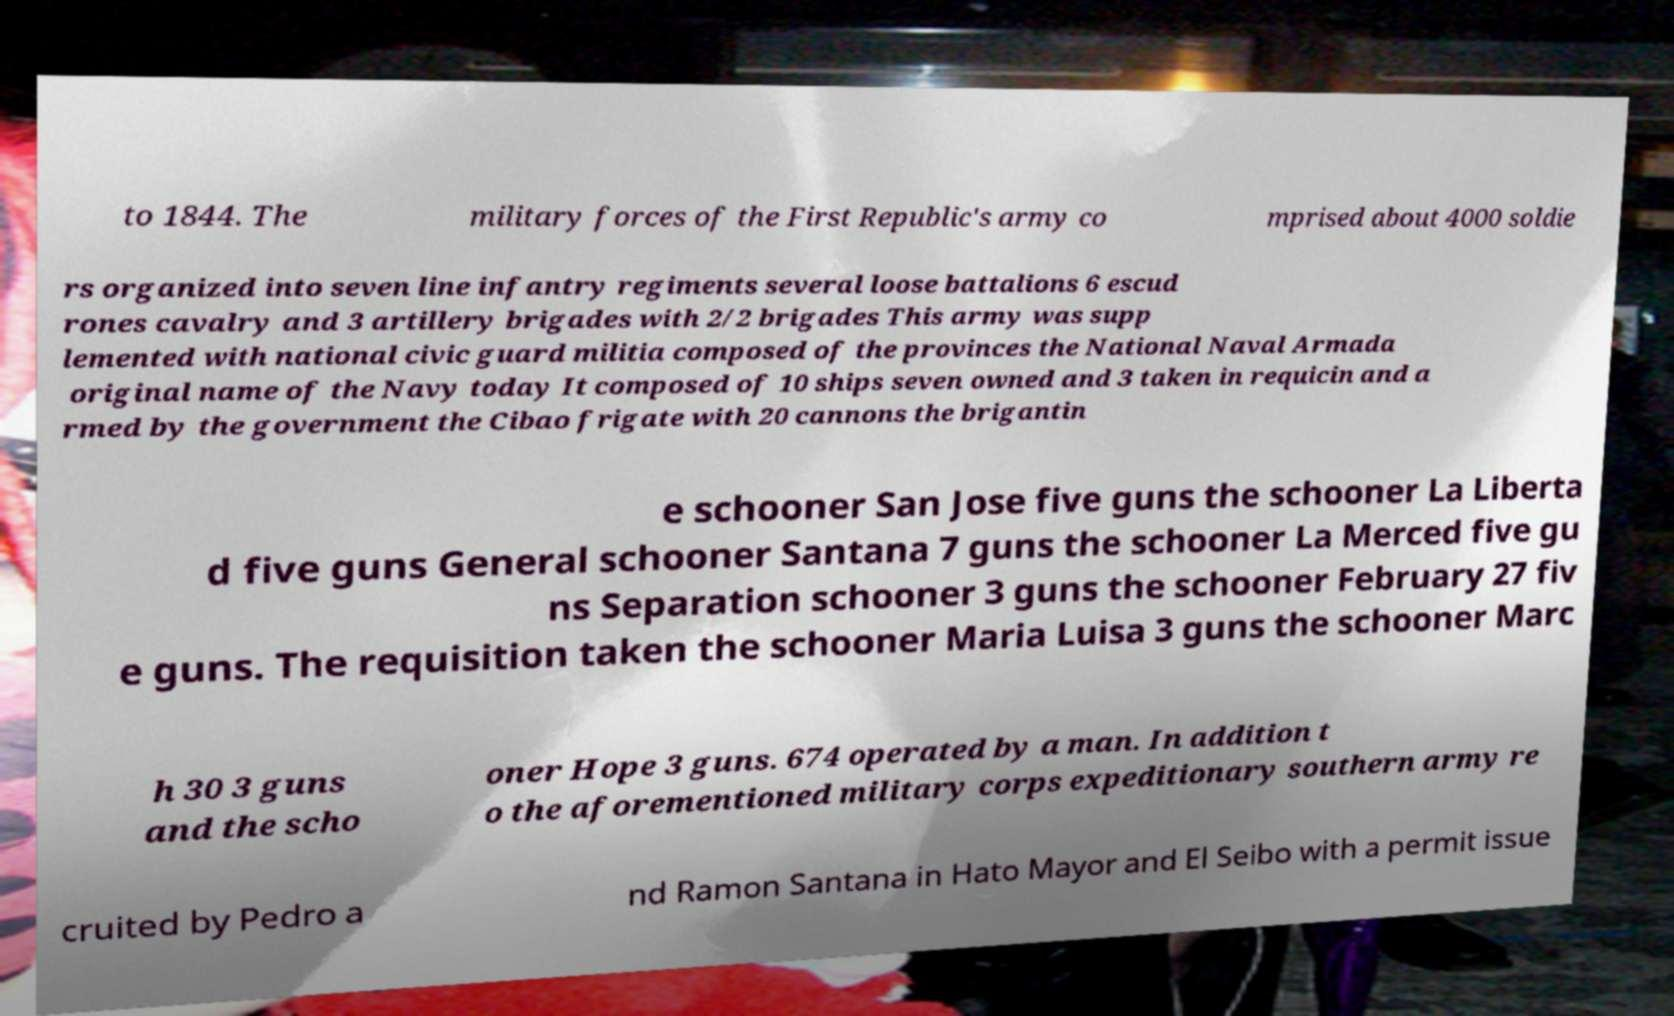Can you read and provide the text displayed in the image?This photo seems to have some interesting text. Can you extract and type it out for me? to 1844. The military forces of the First Republic's army co mprised about 4000 soldie rs organized into seven line infantry regiments several loose battalions 6 escud rones cavalry and 3 artillery brigades with 2/2 brigades This army was supp lemented with national civic guard militia composed of the provinces the National Naval Armada original name of the Navy today It composed of 10 ships seven owned and 3 taken in requicin and a rmed by the government the Cibao frigate with 20 cannons the brigantin e schooner San Jose five guns the schooner La Liberta d five guns General schooner Santana 7 guns the schooner La Merced five gu ns Separation schooner 3 guns the schooner February 27 fiv e guns. The requisition taken the schooner Maria Luisa 3 guns the schooner Marc h 30 3 guns and the scho oner Hope 3 guns. 674 operated by a man. In addition t o the aforementioned military corps expeditionary southern army re cruited by Pedro a nd Ramon Santana in Hato Mayor and El Seibo with a permit issue 